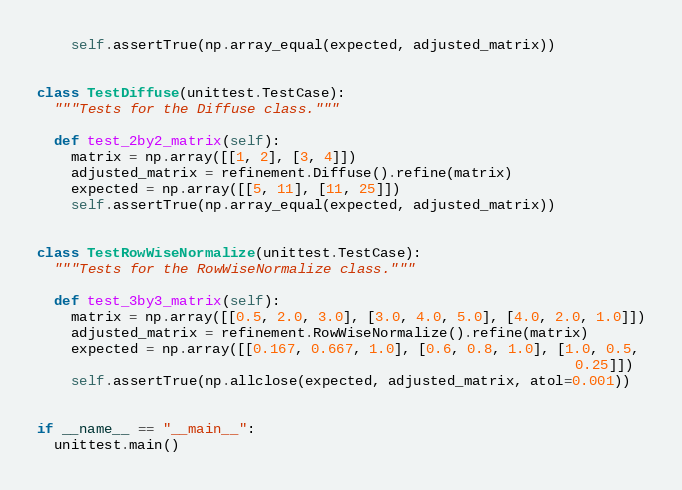Convert code to text. <code><loc_0><loc_0><loc_500><loc_500><_Python_>    self.assertTrue(np.array_equal(expected, adjusted_matrix))


class TestDiffuse(unittest.TestCase):
  """Tests for the Diffuse class."""

  def test_2by2_matrix(self):
    matrix = np.array([[1, 2], [3, 4]])
    adjusted_matrix = refinement.Diffuse().refine(matrix)
    expected = np.array([[5, 11], [11, 25]])
    self.assertTrue(np.array_equal(expected, adjusted_matrix))


class TestRowWiseNormalize(unittest.TestCase):
  """Tests for the RowWiseNormalize class."""

  def test_3by3_matrix(self):
    matrix = np.array([[0.5, 2.0, 3.0], [3.0, 4.0, 5.0], [4.0, 2.0, 1.0]])
    adjusted_matrix = refinement.RowWiseNormalize().refine(matrix)
    expected = np.array([[0.167, 0.667, 1.0], [0.6, 0.8, 1.0], [1.0, 0.5,
                                                                0.25]])
    self.assertTrue(np.allclose(expected, adjusted_matrix, atol=0.001))


if __name__ == "__main__":
  unittest.main()
</code> 